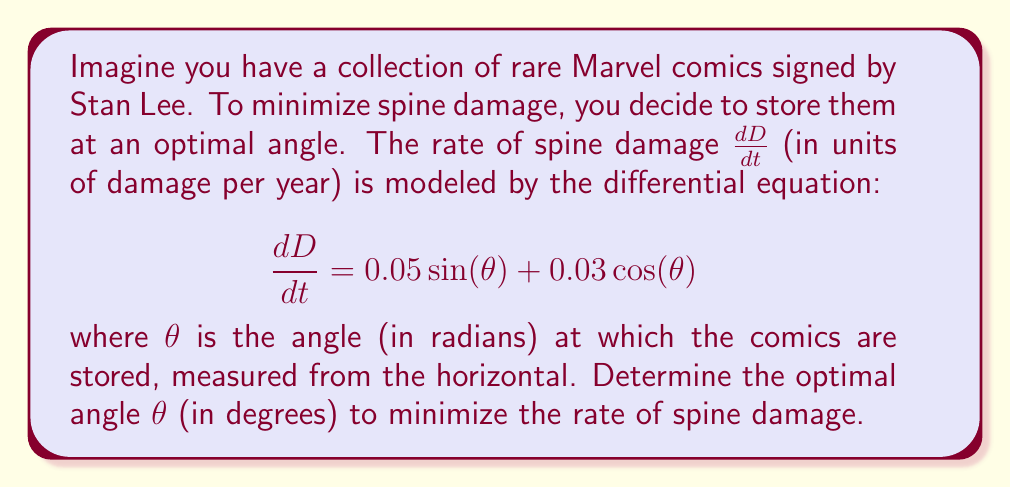Can you answer this question? To find the optimal angle that minimizes the rate of spine damage, we need to find the minimum value of $\frac{dD}{dt}$. This can be done by differentiating $\frac{dD}{dt}$ with respect to $\theta$ and setting it equal to zero:

$$\frac{d}{d\theta}\left(\frac{dD}{dt}\right) = 0.05 \cos(\theta) - 0.03 \sin(\theta) = 0$$

Now, we can solve this equation:

$$0.05 \cos(\theta) = 0.03 \sin(\theta)$$

$$\frac{\cos(\theta)}{\sin(\theta)} = \frac{0.03}{0.05} = 0.6$$

$$\tan(\theta) = \frac{1}{0.6} = \frac{5}{3}$$

$$\theta = \arctan\left(\frac{5}{3}\right)$$

To convert this to degrees, we multiply by $\frac{180}{\pi}$:

$$\theta = \arctan\left(\frac{5}{3}\right) \cdot \frac{180}{\pi} \approx 59.04^\circ$$

To confirm this is a minimum (not a maximum), we can check the second derivative:

$$\frac{d^2}{d\theta^2}\left(\frac{dD}{dt}\right) = -0.05 \sin(\theta) - 0.03 \cos(\theta)$$

Evaluating this at our calculated $\theta$:

$$-0.05 \sin(59.04^\circ) - 0.03 \cos(59.04^\circ) \approx -0.0559 < 0$$

Since the second derivative is negative, this confirms we have found a minimum.
Answer: The optimal angle to store the comic books to minimize spine damage is approximately 59.04°. 